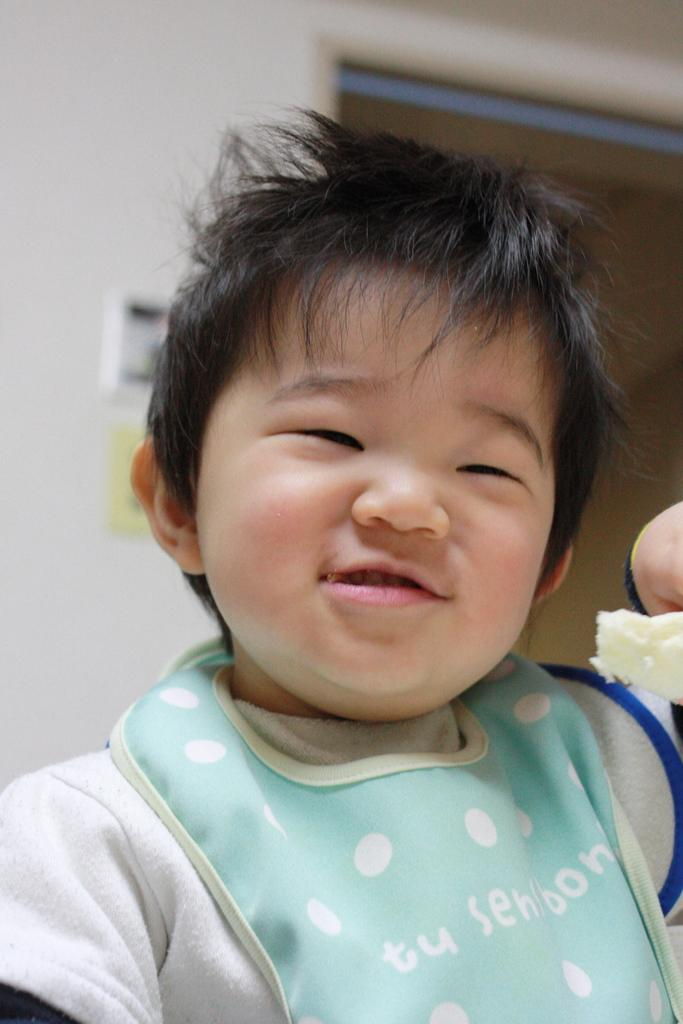Who is present in the image? There is a boy in the image. What is the boy's expression? The boy is smiling. What can be seen in the background of the image? There is a wall in the background of the image. What is the color of the wall? The wall is white in color. What type of caption is written on the wall in the image? There is no caption written on the wall in the image; it is simply a white wall. Can you see any pump or sand in the image? No, there is no pump or sand present in the image. 